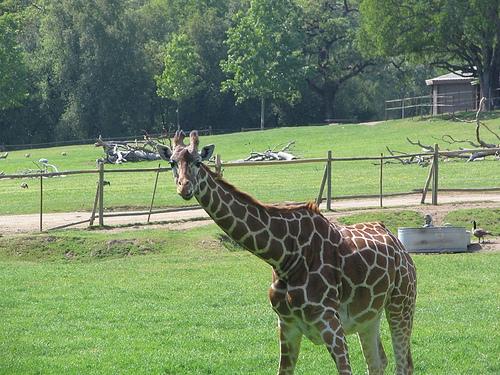Is this indoors?
Write a very short answer. No. Are they in a zoo?
Keep it brief. Yes. Is the giraffe looking away from the camera?
Short answer required. No. 